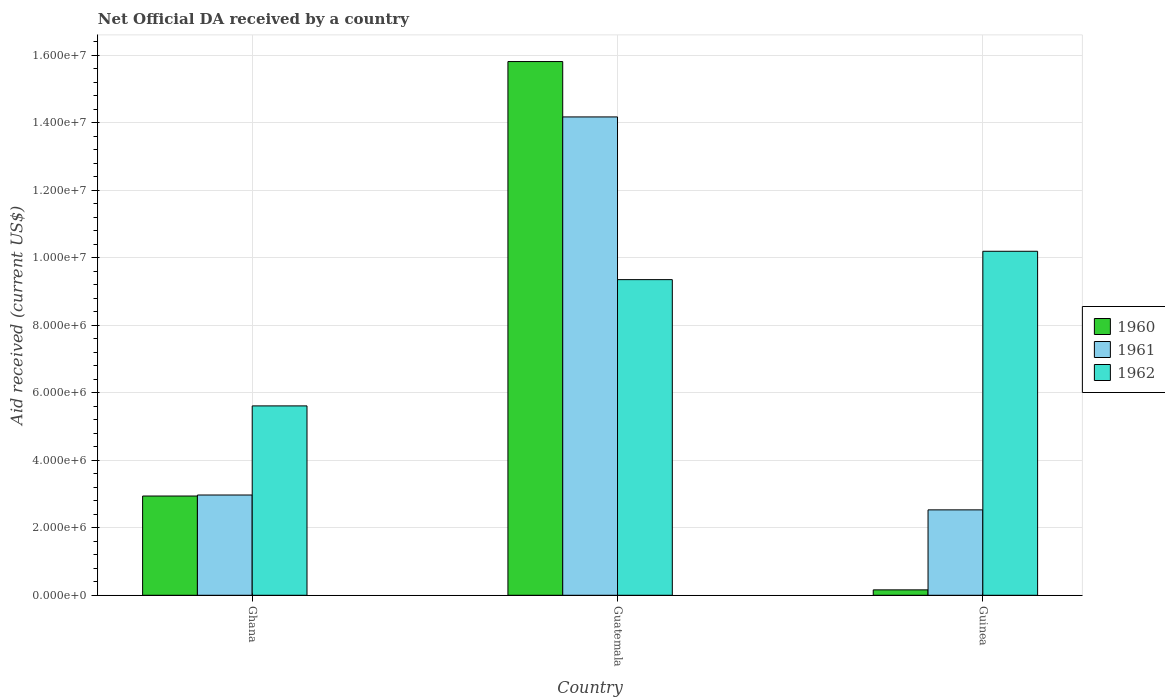How many different coloured bars are there?
Make the answer very short. 3. How many groups of bars are there?
Your answer should be compact. 3. Are the number of bars on each tick of the X-axis equal?
Your answer should be very brief. Yes. How many bars are there on the 2nd tick from the right?
Offer a terse response. 3. What is the label of the 3rd group of bars from the left?
Offer a very short reply. Guinea. In how many cases, is the number of bars for a given country not equal to the number of legend labels?
Keep it short and to the point. 0. What is the net official development assistance aid received in 1962 in Guatemala?
Ensure brevity in your answer.  9.35e+06. Across all countries, what is the maximum net official development assistance aid received in 1961?
Make the answer very short. 1.42e+07. Across all countries, what is the minimum net official development assistance aid received in 1962?
Offer a terse response. 5.61e+06. In which country was the net official development assistance aid received in 1961 maximum?
Provide a succinct answer. Guatemala. In which country was the net official development assistance aid received in 1960 minimum?
Ensure brevity in your answer.  Guinea. What is the total net official development assistance aid received in 1961 in the graph?
Ensure brevity in your answer.  1.97e+07. What is the difference between the net official development assistance aid received in 1961 in Ghana and that in Guatemala?
Provide a succinct answer. -1.12e+07. What is the difference between the net official development assistance aid received in 1961 in Guatemala and the net official development assistance aid received in 1962 in Ghana?
Your response must be concise. 8.56e+06. What is the average net official development assistance aid received in 1960 per country?
Provide a succinct answer. 6.30e+06. What is the difference between the net official development assistance aid received of/in 1960 and net official development assistance aid received of/in 1961 in Guatemala?
Your answer should be very brief. 1.64e+06. In how many countries, is the net official development assistance aid received in 1962 greater than 10000000 US$?
Keep it short and to the point. 1. What is the ratio of the net official development assistance aid received in 1960 in Ghana to that in Guatemala?
Offer a terse response. 0.19. Is the net official development assistance aid received in 1960 in Ghana less than that in Guinea?
Give a very brief answer. No. Is the difference between the net official development assistance aid received in 1960 in Guatemala and Guinea greater than the difference between the net official development assistance aid received in 1961 in Guatemala and Guinea?
Offer a very short reply. Yes. What is the difference between the highest and the second highest net official development assistance aid received in 1962?
Keep it short and to the point. 4.58e+06. What is the difference between the highest and the lowest net official development assistance aid received in 1962?
Ensure brevity in your answer.  4.58e+06. Is the sum of the net official development assistance aid received in 1962 in Ghana and Guinea greater than the maximum net official development assistance aid received in 1960 across all countries?
Make the answer very short. No. How many countries are there in the graph?
Offer a terse response. 3. Are the values on the major ticks of Y-axis written in scientific E-notation?
Offer a very short reply. Yes. Does the graph contain any zero values?
Offer a very short reply. No. Does the graph contain grids?
Offer a very short reply. Yes. Where does the legend appear in the graph?
Ensure brevity in your answer.  Center right. How many legend labels are there?
Ensure brevity in your answer.  3. How are the legend labels stacked?
Make the answer very short. Vertical. What is the title of the graph?
Your answer should be compact. Net Official DA received by a country. What is the label or title of the X-axis?
Provide a succinct answer. Country. What is the label or title of the Y-axis?
Give a very brief answer. Aid received (current US$). What is the Aid received (current US$) of 1960 in Ghana?
Your answer should be very brief. 2.94e+06. What is the Aid received (current US$) of 1961 in Ghana?
Your response must be concise. 2.97e+06. What is the Aid received (current US$) of 1962 in Ghana?
Your answer should be compact. 5.61e+06. What is the Aid received (current US$) of 1960 in Guatemala?
Provide a succinct answer. 1.58e+07. What is the Aid received (current US$) in 1961 in Guatemala?
Make the answer very short. 1.42e+07. What is the Aid received (current US$) in 1962 in Guatemala?
Your answer should be compact. 9.35e+06. What is the Aid received (current US$) of 1961 in Guinea?
Make the answer very short. 2.53e+06. What is the Aid received (current US$) of 1962 in Guinea?
Offer a very short reply. 1.02e+07. Across all countries, what is the maximum Aid received (current US$) of 1960?
Give a very brief answer. 1.58e+07. Across all countries, what is the maximum Aid received (current US$) in 1961?
Your answer should be compact. 1.42e+07. Across all countries, what is the maximum Aid received (current US$) in 1962?
Provide a short and direct response. 1.02e+07. Across all countries, what is the minimum Aid received (current US$) in 1961?
Offer a terse response. 2.53e+06. Across all countries, what is the minimum Aid received (current US$) of 1962?
Your response must be concise. 5.61e+06. What is the total Aid received (current US$) in 1960 in the graph?
Provide a succinct answer. 1.89e+07. What is the total Aid received (current US$) in 1961 in the graph?
Provide a short and direct response. 1.97e+07. What is the total Aid received (current US$) in 1962 in the graph?
Provide a succinct answer. 2.52e+07. What is the difference between the Aid received (current US$) of 1960 in Ghana and that in Guatemala?
Your answer should be very brief. -1.29e+07. What is the difference between the Aid received (current US$) in 1961 in Ghana and that in Guatemala?
Keep it short and to the point. -1.12e+07. What is the difference between the Aid received (current US$) in 1962 in Ghana and that in Guatemala?
Your response must be concise. -3.74e+06. What is the difference between the Aid received (current US$) of 1960 in Ghana and that in Guinea?
Make the answer very short. 2.78e+06. What is the difference between the Aid received (current US$) of 1961 in Ghana and that in Guinea?
Your answer should be compact. 4.40e+05. What is the difference between the Aid received (current US$) in 1962 in Ghana and that in Guinea?
Your response must be concise. -4.58e+06. What is the difference between the Aid received (current US$) in 1960 in Guatemala and that in Guinea?
Make the answer very short. 1.56e+07. What is the difference between the Aid received (current US$) in 1961 in Guatemala and that in Guinea?
Your answer should be very brief. 1.16e+07. What is the difference between the Aid received (current US$) in 1962 in Guatemala and that in Guinea?
Your response must be concise. -8.40e+05. What is the difference between the Aid received (current US$) in 1960 in Ghana and the Aid received (current US$) in 1961 in Guatemala?
Your answer should be compact. -1.12e+07. What is the difference between the Aid received (current US$) of 1960 in Ghana and the Aid received (current US$) of 1962 in Guatemala?
Provide a succinct answer. -6.41e+06. What is the difference between the Aid received (current US$) of 1961 in Ghana and the Aid received (current US$) of 1962 in Guatemala?
Ensure brevity in your answer.  -6.38e+06. What is the difference between the Aid received (current US$) in 1960 in Ghana and the Aid received (current US$) in 1961 in Guinea?
Your answer should be very brief. 4.10e+05. What is the difference between the Aid received (current US$) in 1960 in Ghana and the Aid received (current US$) in 1962 in Guinea?
Provide a succinct answer. -7.25e+06. What is the difference between the Aid received (current US$) in 1961 in Ghana and the Aid received (current US$) in 1962 in Guinea?
Your response must be concise. -7.22e+06. What is the difference between the Aid received (current US$) in 1960 in Guatemala and the Aid received (current US$) in 1961 in Guinea?
Your answer should be compact. 1.33e+07. What is the difference between the Aid received (current US$) in 1960 in Guatemala and the Aid received (current US$) in 1962 in Guinea?
Your answer should be compact. 5.62e+06. What is the difference between the Aid received (current US$) of 1961 in Guatemala and the Aid received (current US$) of 1962 in Guinea?
Your answer should be very brief. 3.98e+06. What is the average Aid received (current US$) in 1960 per country?
Keep it short and to the point. 6.30e+06. What is the average Aid received (current US$) of 1961 per country?
Make the answer very short. 6.56e+06. What is the average Aid received (current US$) in 1962 per country?
Your answer should be compact. 8.38e+06. What is the difference between the Aid received (current US$) in 1960 and Aid received (current US$) in 1961 in Ghana?
Provide a succinct answer. -3.00e+04. What is the difference between the Aid received (current US$) of 1960 and Aid received (current US$) of 1962 in Ghana?
Make the answer very short. -2.67e+06. What is the difference between the Aid received (current US$) in 1961 and Aid received (current US$) in 1962 in Ghana?
Give a very brief answer. -2.64e+06. What is the difference between the Aid received (current US$) of 1960 and Aid received (current US$) of 1961 in Guatemala?
Your answer should be compact. 1.64e+06. What is the difference between the Aid received (current US$) of 1960 and Aid received (current US$) of 1962 in Guatemala?
Make the answer very short. 6.46e+06. What is the difference between the Aid received (current US$) in 1961 and Aid received (current US$) in 1962 in Guatemala?
Provide a succinct answer. 4.82e+06. What is the difference between the Aid received (current US$) in 1960 and Aid received (current US$) in 1961 in Guinea?
Make the answer very short. -2.37e+06. What is the difference between the Aid received (current US$) in 1960 and Aid received (current US$) in 1962 in Guinea?
Make the answer very short. -1.00e+07. What is the difference between the Aid received (current US$) in 1961 and Aid received (current US$) in 1962 in Guinea?
Your answer should be very brief. -7.66e+06. What is the ratio of the Aid received (current US$) of 1960 in Ghana to that in Guatemala?
Ensure brevity in your answer.  0.19. What is the ratio of the Aid received (current US$) in 1961 in Ghana to that in Guatemala?
Ensure brevity in your answer.  0.21. What is the ratio of the Aid received (current US$) in 1962 in Ghana to that in Guatemala?
Offer a very short reply. 0.6. What is the ratio of the Aid received (current US$) in 1960 in Ghana to that in Guinea?
Your answer should be very brief. 18.38. What is the ratio of the Aid received (current US$) in 1961 in Ghana to that in Guinea?
Give a very brief answer. 1.17. What is the ratio of the Aid received (current US$) of 1962 in Ghana to that in Guinea?
Keep it short and to the point. 0.55. What is the ratio of the Aid received (current US$) in 1960 in Guatemala to that in Guinea?
Keep it short and to the point. 98.81. What is the ratio of the Aid received (current US$) in 1961 in Guatemala to that in Guinea?
Offer a very short reply. 5.6. What is the ratio of the Aid received (current US$) in 1962 in Guatemala to that in Guinea?
Your response must be concise. 0.92. What is the difference between the highest and the second highest Aid received (current US$) in 1960?
Offer a terse response. 1.29e+07. What is the difference between the highest and the second highest Aid received (current US$) of 1961?
Your answer should be compact. 1.12e+07. What is the difference between the highest and the second highest Aid received (current US$) in 1962?
Keep it short and to the point. 8.40e+05. What is the difference between the highest and the lowest Aid received (current US$) in 1960?
Make the answer very short. 1.56e+07. What is the difference between the highest and the lowest Aid received (current US$) of 1961?
Ensure brevity in your answer.  1.16e+07. What is the difference between the highest and the lowest Aid received (current US$) of 1962?
Make the answer very short. 4.58e+06. 